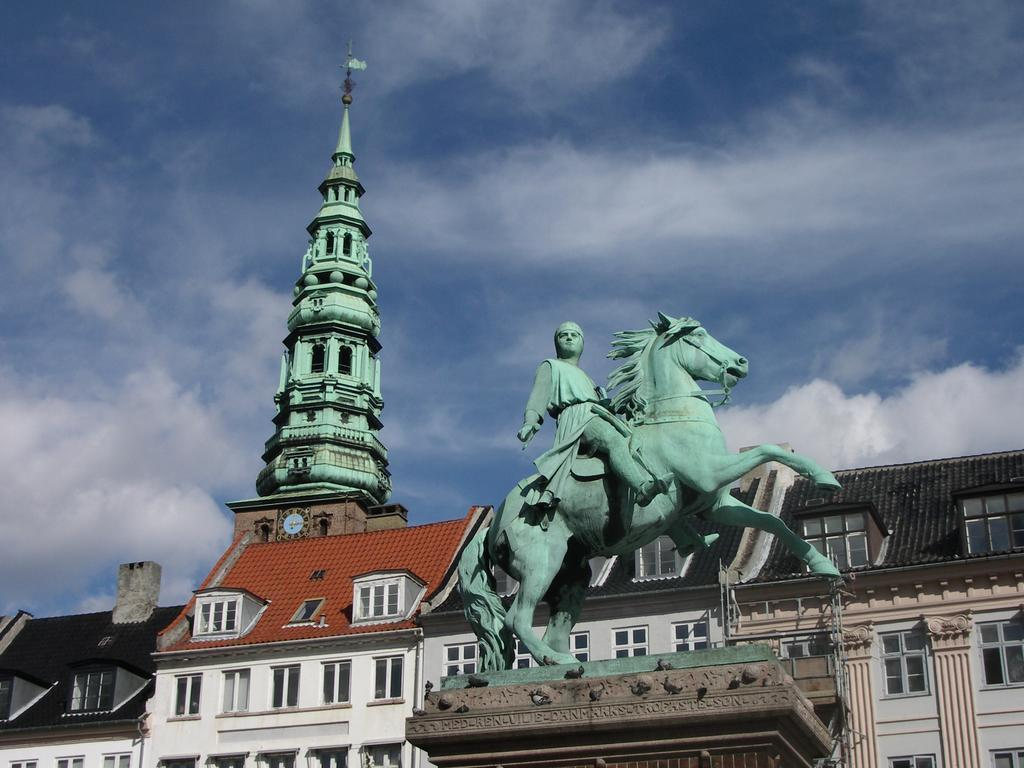What is the main subject of the image? There is a statue of a person on a horse in the image. What can be seen behind the statue? There are buildings behind the statue. Is there any tall structure visible in the background? Yes, there is a tower in the background of the image. What is visible in the sky at the top of the image? Clouds are visible in the sky at the top of the image. How many tramps are visible in the image? There are no tramps present in the image. Can you tell me what type of ticket the person on the horse is holding? There is no ticket visible in the image, and the person on the horse is a statue, so they cannot hold anything. 